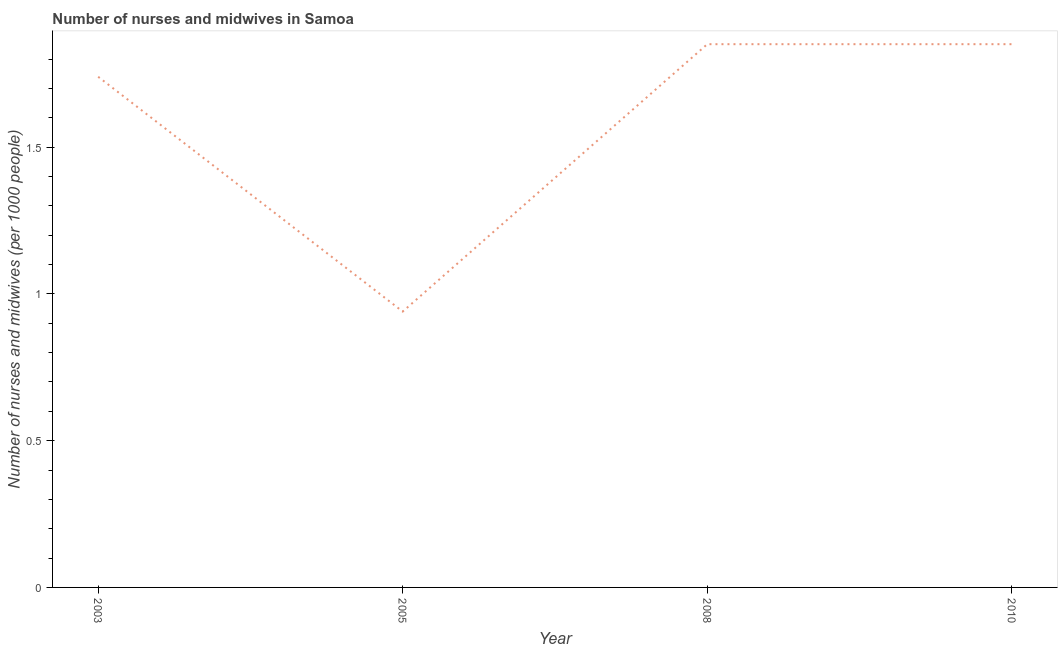Across all years, what is the maximum number of nurses and midwives?
Your answer should be very brief. 1.85. In which year was the number of nurses and midwives maximum?
Provide a short and direct response. 2008. In which year was the number of nurses and midwives minimum?
Give a very brief answer. 2005. What is the sum of the number of nurses and midwives?
Offer a terse response. 6.38. What is the average number of nurses and midwives per year?
Your answer should be very brief. 1.6. What is the median number of nurses and midwives?
Keep it short and to the point. 1.8. In how many years, is the number of nurses and midwives greater than 1.7 ?
Your response must be concise. 3. What is the ratio of the number of nurses and midwives in 2003 to that in 2005?
Offer a terse response. 1.85. What is the difference between the highest and the second highest number of nurses and midwives?
Your response must be concise. 0. Is the sum of the number of nurses and midwives in 2005 and 2010 greater than the maximum number of nurses and midwives across all years?
Your response must be concise. Yes. What is the difference between the highest and the lowest number of nurses and midwives?
Provide a short and direct response. 0.91. Does the graph contain grids?
Your answer should be compact. No. What is the title of the graph?
Ensure brevity in your answer.  Number of nurses and midwives in Samoa. What is the label or title of the Y-axis?
Keep it short and to the point. Number of nurses and midwives (per 1000 people). What is the Number of nurses and midwives (per 1000 people) in 2003?
Your answer should be very brief. 1.74. What is the Number of nurses and midwives (per 1000 people) of 2008?
Keep it short and to the point. 1.85. What is the Number of nurses and midwives (per 1000 people) in 2010?
Your answer should be very brief. 1.85. What is the difference between the Number of nurses and midwives (per 1000 people) in 2003 and 2005?
Offer a very short reply. 0.8. What is the difference between the Number of nurses and midwives (per 1000 people) in 2003 and 2008?
Your response must be concise. -0.11. What is the difference between the Number of nurses and midwives (per 1000 people) in 2003 and 2010?
Your answer should be very brief. -0.11. What is the difference between the Number of nurses and midwives (per 1000 people) in 2005 and 2008?
Offer a very short reply. -0.91. What is the difference between the Number of nurses and midwives (per 1000 people) in 2005 and 2010?
Make the answer very short. -0.91. What is the difference between the Number of nurses and midwives (per 1000 people) in 2008 and 2010?
Keep it short and to the point. 0. What is the ratio of the Number of nurses and midwives (per 1000 people) in 2003 to that in 2005?
Provide a succinct answer. 1.85. What is the ratio of the Number of nurses and midwives (per 1000 people) in 2005 to that in 2008?
Make the answer very short. 0.51. What is the ratio of the Number of nurses and midwives (per 1000 people) in 2005 to that in 2010?
Your response must be concise. 0.51. What is the ratio of the Number of nurses and midwives (per 1000 people) in 2008 to that in 2010?
Make the answer very short. 1. 